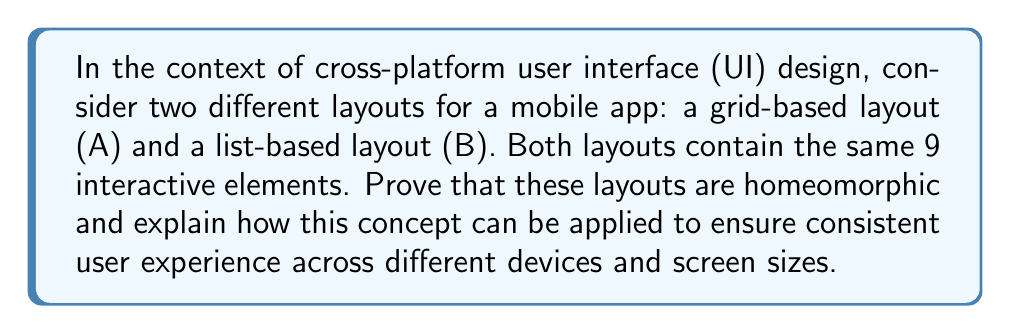Give your solution to this math problem. To prove that the grid-based layout (A) and the list-based layout (B) are homeomorphic, we need to show that there exists a continuous bijective function with a continuous inverse between them. Let's approach this step-by-step:

1. Representation:
   Let's represent layout A as a 3x3 grid and layout B as a vertical list of 9 elements.

   Layout A (Grid):
   $$
   \begin{bmatrix}
   1 & 2 & 3 \\
   4 & 5 & 6 \\
   7 & 8 & 9
   \end{bmatrix}
   $$

   Layout B (List):
   $$
   \begin{bmatrix}
   1 \\ 2 \\ 3 \\ 4 \\ 5 \\ 6 \\ 7 \\ 8 \\ 9
   \end{bmatrix}
   $$

2. Bijective function:
   We can define a function $f: A \rightarrow B$ that maps each element in the grid to its corresponding position in the list. This function is bijective as each element in A has a unique corresponding element in B, and vice versa.

3. Continuity:
   In the context of UI layouts, we can consider "continuity" as the preservation of adjacency and order of elements. The function $f$ preserves the order of elements (1 to 9) and maintains relative adjacency (e.g., element 1 is still "next to" element 2 in both layouts).

4. Continuous inverse:
   The inverse function $f^{-1}: B \rightarrow A$ that maps the list back to the grid is also continuous in the same sense.

5. Deformation:
   We can imagine continuously deforming the grid layout into the list layout without tearing or gluing, which is a key property of homeomorphisms.

Application to cross-platform compatibility:

1. Consistent user experience: Since the layouts are homeomorphic, the essential structure and relationships between UI elements are preserved, ensuring a consistent user experience across different devices.

2. Adaptive layouts: Developers can create algorithms that automatically transform layouts between homeomorphic configurations based on screen size or device type.

3. Preservation of functionality: The homeomorphic relationship ensures that all interactive elements are present and accessible in both layouts, maintaining full functionality across platforms.

4. Efficient development: Understanding the homeomorphic relationship between layouts allows developers to create a single, flexible UI design that can be easily adapted to multiple platforms.

5. User interface testing: Testers can verify that the user experience remains consistent across platforms by checking that the homeomorphic properties are maintained during layout transformations.
Answer: The grid-based layout (A) and the list-based layout (B) are homeomorphic. This concept can be applied to ensure consistent user experience across different devices and screen sizes by preserving the essential structure and relationships between UI elements, enabling adaptive layouts, maintaining functionality, facilitating efficient development, and simplifying cross-platform testing. 